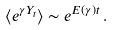<formula> <loc_0><loc_0><loc_500><loc_500>\langle e ^ { \gamma Y _ { t } } \rangle \sim e ^ { E ( \gamma ) t } \, .</formula> 